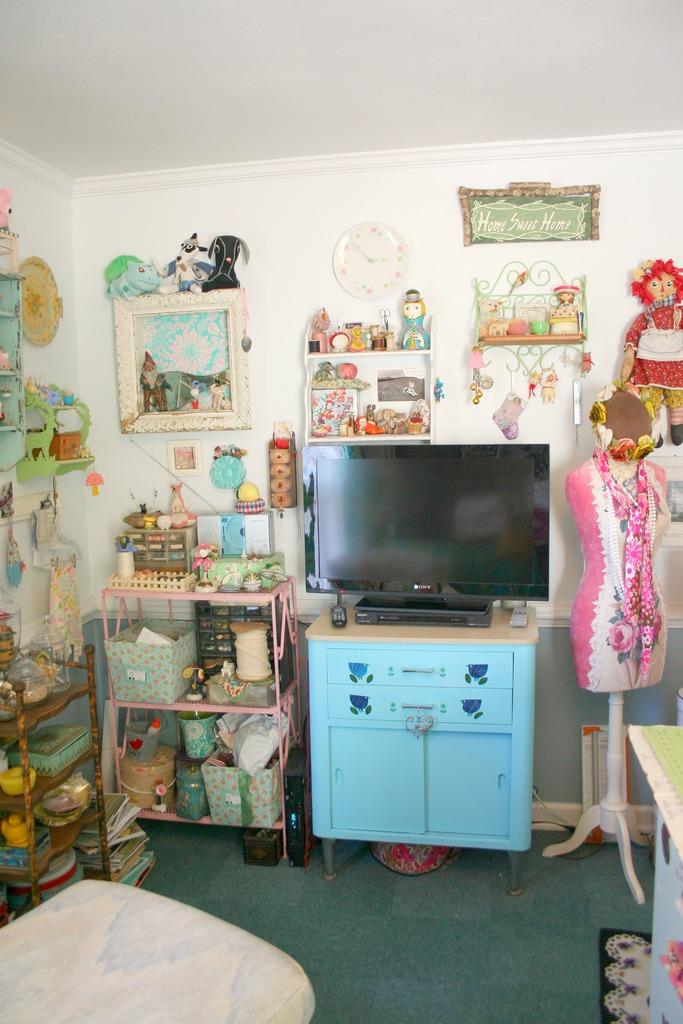What does the green sign say?
Your answer should be compact. Home sweet home. 